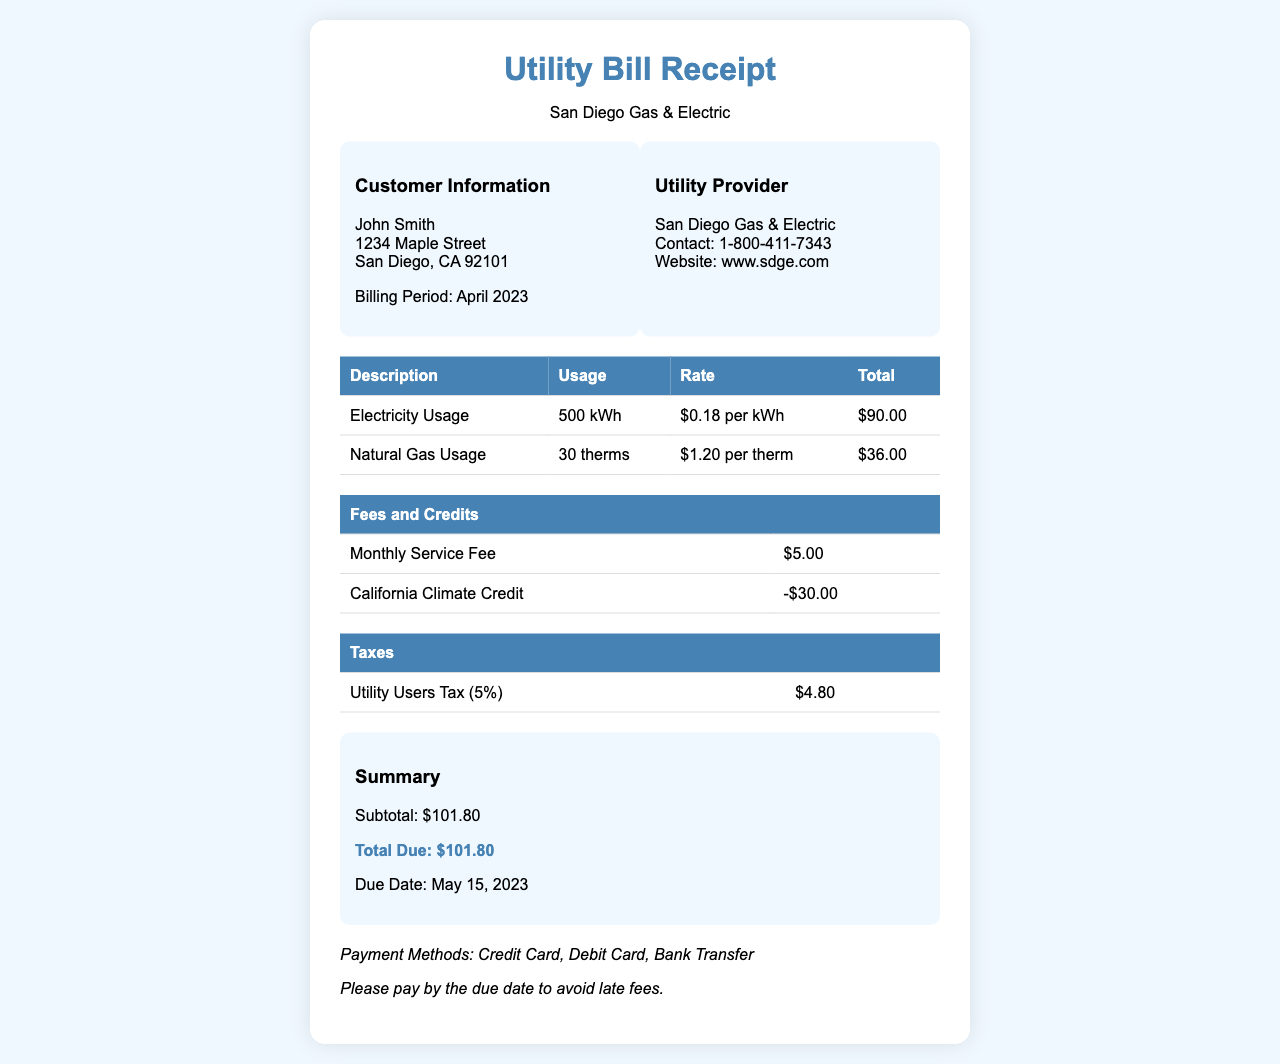What is the total due for April 2023? The total due for April 2023 is indicated in the summary section of the document.
Answer: $101.80 Who is the customer? The customer name is provided in the customer information section at the top of the document.
Answer: John Smith What is the billing period? The billing period is mentioned in the customer information section, specifying the time frame for the charges.
Answer: April 2023 How many kilowatt-hours of electricity were used? The document details the electricity usage in the table dedicated to usage charges.
Answer: 500 kWh What is the monthly service fee? This fee is listed in the fees and credits table, indicating the fixed charge for service.
Answer: $5.00 What is the due date for the payment? The due date is specified in the summary section of the document, indicating when the payment is due.
Answer: May 15, 2023 How much is the California Climate Credit? The amount of this credit is noted in the fees and credits table, showing a reduction in charges.
Answer: -$30.00 What is the rate for natural gas usage? The rate for natural gas usage is given in the usage charges table, specifying how much is charged per therm.
Answer: $1.20 per therm What tax is applied to the utility bill? The specific tax levied on the bill is mentioned in the taxes section, detailing the type of tax and its percentage.
Answer: Utility Users Tax (5%) 